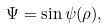<formula> <loc_0><loc_0><loc_500><loc_500>\Psi = \sin \psi ( \rho ) ,</formula> 